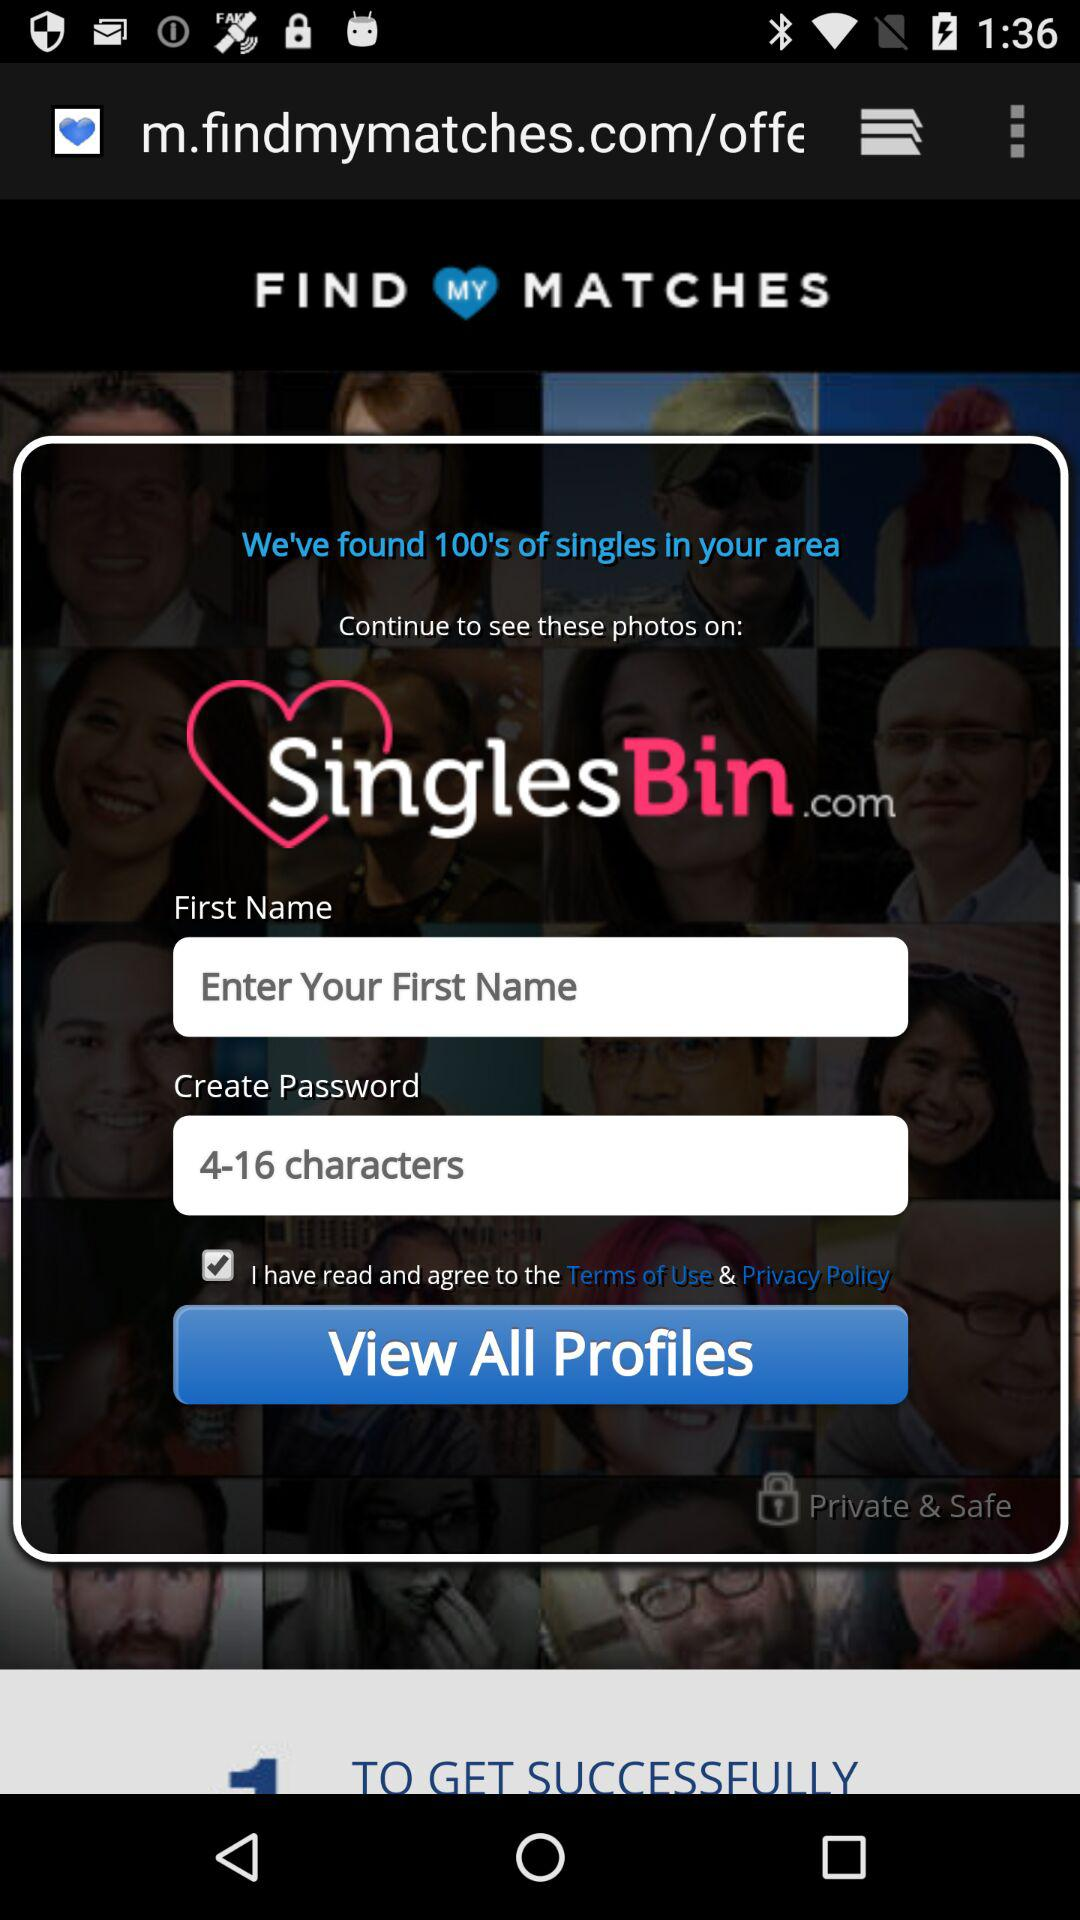What is the range of characters to create a password? The range of characters to create a password is from 4 to 16. 